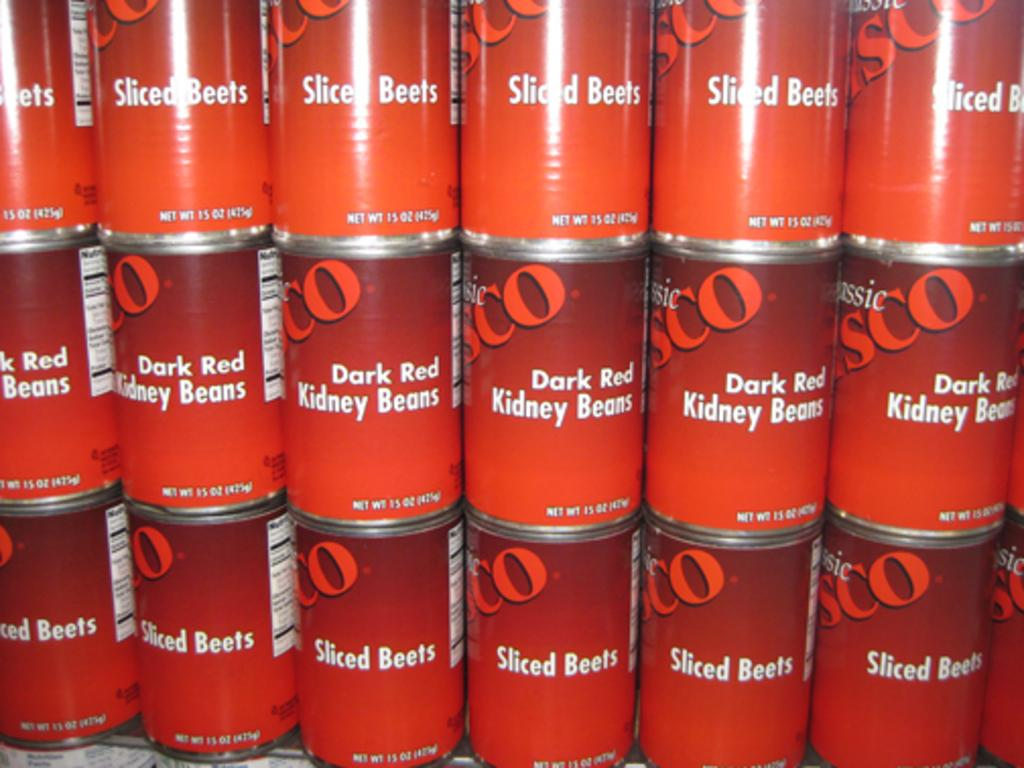<image>
Write a terse but informative summary of the picture. Cans of Sliced Beets and Dark Red Kidney Beans. 